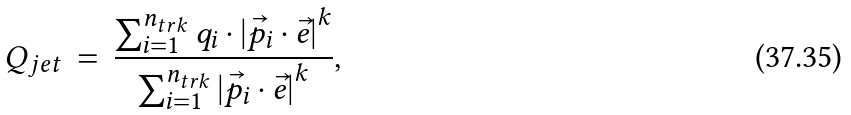Convert formula to latex. <formula><loc_0><loc_0><loc_500><loc_500>Q _ { j e t } \, = \, \frac { \sum _ { i = 1 } ^ { n _ { t r k } } q _ { i } \cdot { | { \vec { p _ { i } } \cdot { \vec { e } } } | } ^ { k } } { \sum _ { i = 1 } ^ { n _ { t r k } } { | { \vec { p _ { i } } \cdot { \vec { e } } } | } ^ { k } } ,</formula> 